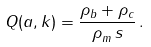<formula> <loc_0><loc_0><loc_500><loc_500>Q ( a , k ) = \frac { \rho _ { b } + \rho _ { c } } { \rho _ { m } ^ { \ } s } \, .</formula> 